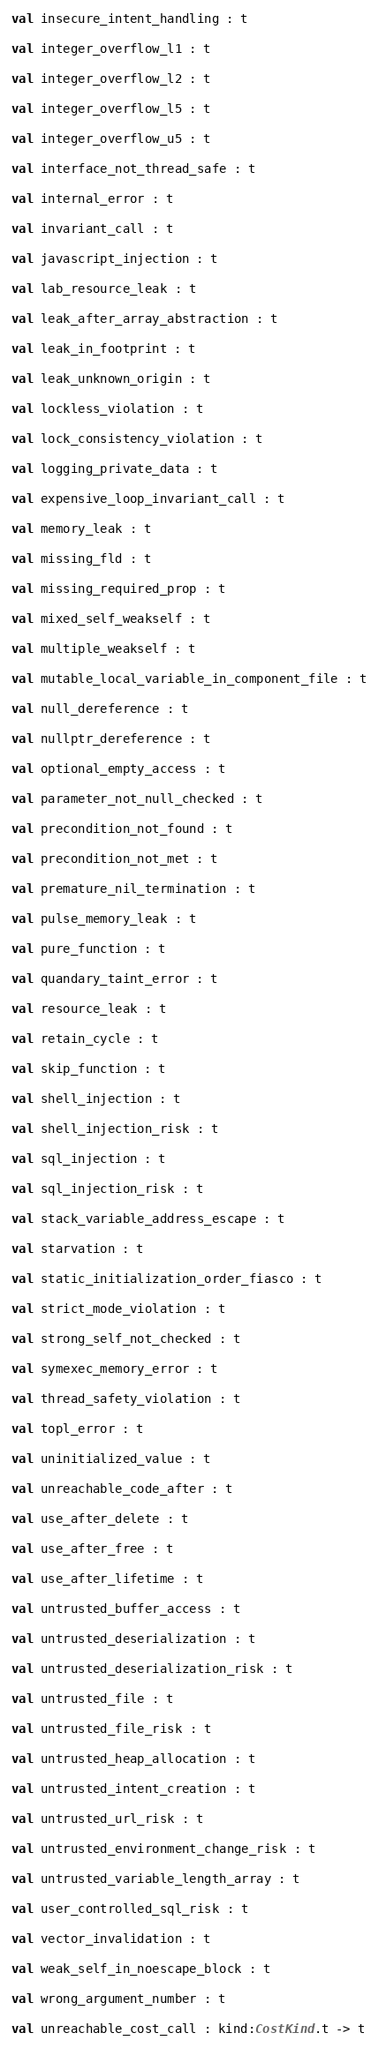Convert code to text. <code><loc_0><loc_0><loc_500><loc_500><_OCaml_>val insecure_intent_handling : t

val integer_overflow_l1 : t

val integer_overflow_l2 : t

val integer_overflow_l5 : t

val integer_overflow_u5 : t

val interface_not_thread_safe : t

val internal_error : t

val invariant_call : t

val javascript_injection : t

val lab_resource_leak : t

val leak_after_array_abstraction : t

val leak_in_footprint : t

val leak_unknown_origin : t

val lockless_violation : t

val lock_consistency_violation : t

val logging_private_data : t

val expensive_loop_invariant_call : t

val memory_leak : t

val missing_fld : t

val missing_required_prop : t

val mixed_self_weakself : t

val multiple_weakself : t

val mutable_local_variable_in_component_file : t

val null_dereference : t

val nullptr_dereference : t

val optional_empty_access : t

val parameter_not_null_checked : t

val precondition_not_found : t

val precondition_not_met : t

val premature_nil_termination : t

val pulse_memory_leak : t

val pure_function : t

val quandary_taint_error : t

val resource_leak : t

val retain_cycle : t

val skip_function : t

val shell_injection : t

val shell_injection_risk : t

val sql_injection : t

val sql_injection_risk : t

val stack_variable_address_escape : t

val starvation : t

val static_initialization_order_fiasco : t

val strict_mode_violation : t

val strong_self_not_checked : t

val symexec_memory_error : t

val thread_safety_violation : t

val topl_error : t

val uninitialized_value : t

val unreachable_code_after : t

val use_after_delete : t

val use_after_free : t

val use_after_lifetime : t

val untrusted_buffer_access : t

val untrusted_deserialization : t

val untrusted_deserialization_risk : t

val untrusted_file : t

val untrusted_file_risk : t

val untrusted_heap_allocation : t

val untrusted_intent_creation : t

val untrusted_url_risk : t

val untrusted_environment_change_risk : t

val untrusted_variable_length_array : t

val user_controlled_sql_risk : t

val vector_invalidation : t

val weak_self_in_noescape_block : t

val wrong_argument_number : t

val unreachable_cost_call : kind:CostKind.t -> t
</code> 